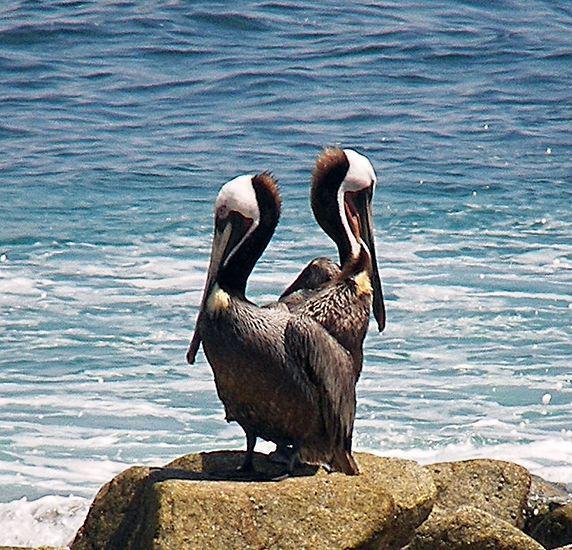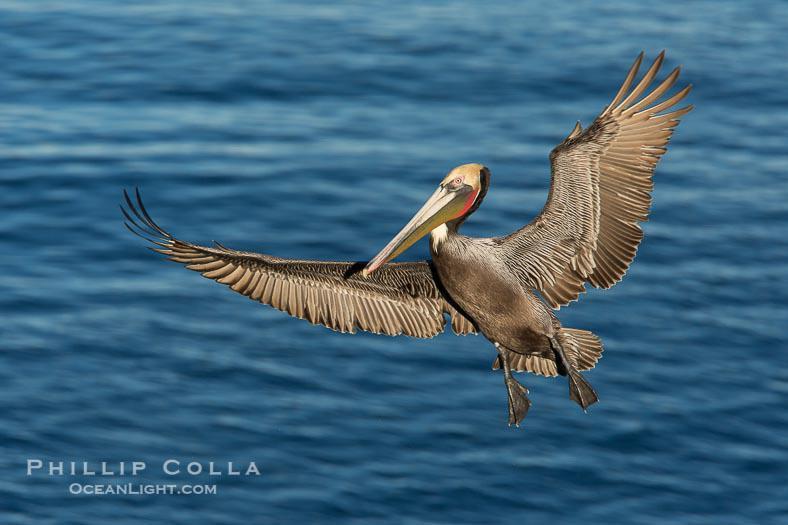The first image is the image on the left, the second image is the image on the right. Assess this claim about the two images: "The bird in the right image is facing towards the left.". Correct or not? Answer yes or no. Yes. The first image is the image on the left, the second image is the image on the right. Considering the images on both sides, is "A single bird is flying over the water in the image on the left." valid? Answer yes or no. No. 